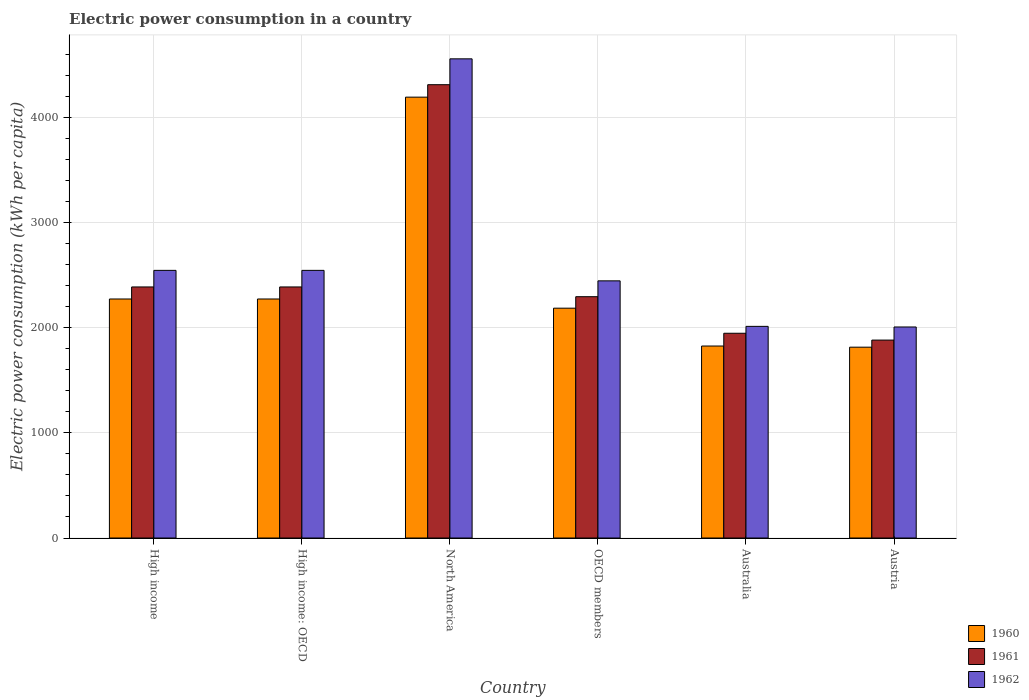What is the electric power consumption in in 1961 in High income?
Offer a terse response. 2387.51. Across all countries, what is the maximum electric power consumption in in 1962?
Provide a succinct answer. 4556.78. Across all countries, what is the minimum electric power consumption in in 1961?
Offer a very short reply. 1882.22. In which country was the electric power consumption in in 1961 minimum?
Give a very brief answer. Austria. What is the total electric power consumption in in 1961 in the graph?
Your answer should be very brief. 1.52e+04. What is the difference between the electric power consumption in in 1962 in Australia and that in North America?
Keep it short and to the point. -2544.12. What is the difference between the electric power consumption in in 1962 in High income and the electric power consumption in in 1960 in Australia?
Make the answer very short. 719.61. What is the average electric power consumption in in 1960 per country?
Your answer should be compact. 2427.36. What is the difference between the electric power consumption in of/in 1960 and electric power consumption in of/in 1962 in Australia?
Your response must be concise. -187.03. In how many countries, is the electric power consumption in in 1961 greater than 3000 kWh per capita?
Your response must be concise. 1. What is the ratio of the electric power consumption in in 1960 in Austria to that in OECD members?
Provide a short and direct response. 0.83. Is the electric power consumption in in 1962 in Australia less than that in Austria?
Keep it short and to the point. No. What is the difference between the highest and the second highest electric power consumption in in 1960?
Ensure brevity in your answer.  1919.38. What is the difference between the highest and the lowest electric power consumption in in 1960?
Ensure brevity in your answer.  2377.68. What does the 2nd bar from the left in Austria represents?
Offer a terse response. 1961. What does the 1st bar from the right in High income: OECD represents?
Give a very brief answer. 1962. How many legend labels are there?
Give a very brief answer. 3. What is the title of the graph?
Keep it short and to the point. Electric power consumption in a country. What is the label or title of the X-axis?
Provide a succinct answer. Country. What is the label or title of the Y-axis?
Offer a very short reply. Electric power consumption (kWh per capita). What is the Electric power consumption (kWh per capita) of 1960 in High income?
Provide a succinct answer. 2272.98. What is the Electric power consumption (kWh per capita) of 1961 in High income?
Ensure brevity in your answer.  2387.51. What is the Electric power consumption (kWh per capita) in 1962 in High income?
Your response must be concise. 2545.23. What is the Electric power consumption (kWh per capita) of 1960 in High income: OECD?
Ensure brevity in your answer.  2272.98. What is the Electric power consumption (kWh per capita) in 1961 in High income: OECD?
Offer a very short reply. 2387.51. What is the Electric power consumption (kWh per capita) in 1962 in High income: OECD?
Offer a very short reply. 2545.23. What is the Electric power consumption (kWh per capita) in 1960 in North America?
Offer a terse response. 4192.36. What is the Electric power consumption (kWh per capita) in 1961 in North America?
Ensure brevity in your answer.  4310.91. What is the Electric power consumption (kWh per capita) in 1962 in North America?
Provide a short and direct response. 4556.78. What is the Electric power consumption (kWh per capita) in 1960 in OECD members?
Ensure brevity in your answer.  2185.53. What is the Electric power consumption (kWh per capita) in 1961 in OECD members?
Provide a short and direct response. 2294.73. What is the Electric power consumption (kWh per capita) in 1962 in OECD members?
Offer a very short reply. 2445.52. What is the Electric power consumption (kWh per capita) of 1960 in Australia?
Your response must be concise. 1825.63. What is the Electric power consumption (kWh per capita) of 1961 in Australia?
Your answer should be very brief. 1947.15. What is the Electric power consumption (kWh per capita) in 1962 in Australia?
Provide a succinct answer. 2012.66. What is the Electric power consumption (kWh per capita) in 1960 in Austria?
Offer a terse response. 1814.68. What is the Electric power consumption (kWh per capita) of 1961 in Austria?
Your answer should be compact. 1882.22. What is the Electric power consumption (kWh per capita) of 1962 in Austria?
Offer a terse response. 2006.77. Across all countries, what is the maximum Electric power consumption (kWh per capita) of 1960?
Provide a short and direct response. 4192.36. Across all countries, what is the maximum Electric power consumption (kWh per capita) of 1961?
Offer a terse response. 4310.91. Across all countries, what is the maximum Electric power consumption (kWh per capita) of 1962?
Make the answer very short. 4556.78. Across all countries, what is the minimum Electric power consumption (kWh per capita) in 1960?
Your answer should be very brief. 1814.68. Across all countries, what is the minimum Electric power consumption (kWh per capita) in 1961?
Offer a terse response. 1882.22. Across all countries, what is the minimum Electric power consumption (kWh per capita) of 1962?
Ensure brevity in your answer.  2006.77. What is the total Electric power consumption (kWh per capita) of 1960 in the graph?
Offer a very short reply. 1.46e+04. What is the total Electric power consumption (kWh per capita) in 1961 in the graph?
Provide a short and direct response. 1.52e+04. What is the total Electric power consumption (kWh per capita) in 1962 in the graph?
Your answer should be very brief. 1.61e+04. What is the difference between the Electric power consumption (kWh per capita) of 1960 in High income and that in High income: OECD?
Provide a short and direct response. 0. What is the difference between the Electric power consumption (kWh per capita) of 1961 in High income and that in High income: OECD?
Give a very brief answer. 0. What is the difference between the Electric power consumption (kWh per capita) in 1960 in High income and that in North America?
Offer a terse response. -1919.38. What is the difference between the Electric power consumption (kWh per capita) of 1961 in High income and that in North America?
Give a very brief answer. -1923.4. What is the difference between the Electric power consumption (kWh per capita) in 1962 in High income and that in North America?
Your answer should be compact. -2011.55. What is the difference between the Electric power consumption (kWh per capita) of 1960 in High income and that in OECD members?
Keep it short and to the point. 87.44. What is the difference between the Electric power consumption (kWh per capita) in 1961 in High income and that in OECD members?
Make the answer very short. 92.77. What is the difference between the Electric power consumption (kWh per capita) in 1962 in High income and that in OECD members?
Your answer should be compact. 99.71. What is the difference between the Electric power consumption (kWh per capita) in 1960 in High income and that in Australia?
Offer a terse response. 447.35. What is the difference between the Electric power consumption (kWh per capita) in 1961 in High income and that in Australia?
Offer a very short reply. 440.35. What is the difference between the Electric power consumption (kWh per capita) of 1962 in High income and that in Australia?
Offer a very short reply. 532.57. What is the difference between the Electric power consumption (kWh per capita) in 1960 in High income and that in Austria?
Make the answer very short. 458.3. What is the difference between the Electric power consumption (kWh per capita) of 1961 in High income and that in Austria?
Your answer should be very brief. 505.28. What is the difference between the Electric power consumption (kWh per capita) of 1962 in High income and that in Austria?
Provide a short and direct response. 538.46. What is the difference between the Electric power consumption (kWh per capita) in 1960 in High income: OECD and that in North America?
Offer a terse response. -1919.38. What is the difference between the Electric power consumption (kWh per capita) in 1961 in High income: OECD and that in North America?
Offer a terse response. -1923.4. What is the difference between the Electric power consumption (kWh per capita) of 1962 in High income: OECD and that in North America?
Keep it short and to the point. -2011.55. What is the difference between the Electric power consumption (kWh per capita) of 1960 in High income: OECD and that in OECD members?
Offer a very short reply. 87.44. What is the difference between the Electric power consumption (kWh per capita) of 1961 in High income: OECD and that in OECD members?
Offer a terse response. 92.77. What is the difference between the Electric power consumption (kWh per capita) in 1962 in High income: OECD and that in OECD members?
Provide a succinct answer. 99.71. What is the difference between the Electric power consumption (kWh per capita) in 1960 in High income: OECD and that in Australia?
Your answer should be compact. 447.35. What is the difference between the Electric power consumption (kWh per capita) of 1961 in High income: OECD and that in Australia?
Your answer should be compact. 440.35. What is the difference between the Electric power consumption (kWh per capita) of 1962 in High income: OECD and that in Australia?
Offer a terse response. 532.57. What is the difference between the Electric power consumption (kWh per capita) in 1960 in High income: OECD and that in Austria?
Provide a short and direct response. 458.3. What is the difference between the Electric power consumption (kWh per capita) in 1961 in High income: OECD and that in Austria?
Your response must be concise. 505.28. What is the difference between the Electric power consumption (kWh per capita) of 1962 in High income: OECD and that in Austria?
Give a very brief answer. 538.46. What is the difference between the Electric power consumption (kWh per capita) in 1960 in North America and that in OECD members?
Ensure brevity in your answer.  2006.82. What is the difference between the Electric power consumption (kWh per capita) of 1961 in North America and that in OECD members?
Your answer should be very brief. 2016.17. What is the difference between the Electric power consumption (kWh per capita) in 1962 in North America and that in OECD members?
Keep it short and to the point. 2111.25. What is the difference between the Electric power consumption (kWh per capita) of 1960 in North America and that in Australia?
Your response must be concise. 2366.73. What is the difference between the Electric power consumption (kWh per capita) of 1961 in North America and that in Australia?
Offer a very short reply. 2363.75. What is the difference between the Electric power consumption (kWh per capita) in 1962 in North America and that in Australia?
Provide a short and direct response. 2544.12. What is the difference between the Electric power consumption (kWh per capita) of 1960 in North America and that in Austria?
Give a very brief answer. 2377.68. What is the difference between the Electric power consumption (kWh per capita) of 1961 in North America and that in Austria?
Your answer should be very brief. 2428.68. What is the difference between the Electric power consumption (kWh per capita) in 1962 in North America and that in Austria?
Make the answer very short. 2550.01. What is the difference between the Electric power consumption (kWh per capita) in 1960 in OECD members and that in Australia?
Your answer should be compact. 359.91. What is the difference between the Electric power consumption (kWh per capita) in 1961 in OECD members and that in Australia?
Offer a very short reply. 347.58. What is the difference between the Electric power consumption (kWh per capita) in 1962 in OECD members and that in Australia?
Make the answer very short. 432.86. What is the difference between the Electric power consumption (kWh per capita) in 1960 in OECD members and that in Austria?
Make the answer very short. 370.86. What is the difference between the Electric power consumption (kWh per capita) in 1961 in OECD members and that in Austria?
Provide a succinct answer. 412.51. What is the difference between the Electric power consumption (kWh per capita) in 1962 in OECD members and that in Austria?
Make the answer very short. 438.75. What is the difference between the Electric power consumption (kWh per capita) in 1960 in Australia and that in Austria?
Provide a short and direct response. 10.95. What is the difference between the Electric power consumption (kWh per capita) of 1961 in Australia and that in Austria?
Your response must be concise. 64.93. What is the difference between the Electric power consumption (kWh per capita) in 1962 in Australia and that in Austria?
Offer a terse response. 5.89. What is the difference between the Electric power consumption (kWh per capita) in 1960 in High income and the Electric power consumption (kWh per capita) in 1961 in High income: OECD?
Ensure brevity in your answer.  -114.53. What is the difference between the Electric power consumption (kWh per capita) of 1960 in High income and the Electric power consumption (kWh per capita) of 1962 in High income: OECD?
Make the answer very short. -272.26. What is the difference between the Electric power consumption (kWh per capita) of 1961 in High income and the Electric power consumption (kWh per capita) of 1962 in High income: OECD?
Provide a succinct answer. -157.73. What is the difference between the Electric power consumption (kWh per capita) in 1960 in High income and the Electric power consumption (kWh per capita) in 1961 in North America?
Offer a terse response. -2037.93. What is the difference between the Electric power consumption (kWh per capita) of 1960 in High income and the Electric power consumption (kWh per capita) of 1962 in North America?
Provide a short and direct response. -2283.8. What is the difference between the Electric power consumption (kWh per capita) in 1961 in High income and the Electric power consumption (kWh per capita) in 1962 in North America?
Offer a very short reply. -2169.27. What is the difference between the Electric power consumption (kWh per capita) of 1960 in High income and the Electric power consumption (kWh per capita) of 1961 in OECD members?
Provide a succinct answer. -21.76. What is the difference between the Electric power consumption (kWh per capita) of 1960 in High income and the Electric power consumption (kWh per capita) of 1962 in OECD members?
Offer a very short reply. -172.55. What is the difference between the Electric power consumption (kWh per capita) in 1961 in High income and the Electric power consumption (kWh per capita) in 1962 in OECD members?
Give a very brief answer. -58.02. What is the difference between the Electric power consumption (kWh per capita) of 1960 in High income and the Electric power consumption (kWh per capita) of 1961 in Australia?
Offer a very short reply. 325.82. What is the difference between the Electric power consumption (kWh per capita) of 1960 in High income and the Electric power consumption (kWh per capita) of 1962 in Australia?
Keep it short and to the point. 260.32. What is the difference between the Electric power consumption (kWh per capita) of 1961 in High income and the Electric power consumption (kWh per capita) of 1962 in Australia?
Make the answer very short. 374.84. What is the difference between the Electric power consumption (kWh per capita) of 1960 in High income and the Electric power consumption (kWh per capita) of 1961 in Austria?
Make the answer very short. 390.75. What is the difference between the Electric power consumption (kWh per capita) of 1960 in High income and the Electric power consumption (kWh per capita) of 1962 in Austria?
Your answer should be very brief. 266.21. What is the difference between the Electric power consumption (kWh per capita) in 1961 in High income and the Electric power consumption (kWh per capita) in 1962 in Austria?
Give a very brief answer. 380.73. What is the difference between the Electric power consumption (kWh per capita) in 1960 in High income: OECD and the Electric power consumption (kWh per capita) in 1961 in North America?
Your answer should be compact. -2037.93. What is the difference between the Electric power consumption (kWh per capita) in 1960 in High income: OECD and the Electric power consumption (kWh per capita) in 1962 in North America?
Give a very brief answer. -2283.8. What is the difference between the Electric power consumption (kWh per capita) in 1961 in High income: OECD and the Electric power consumption (kWh per capita) in 1962 in North America?
Make the answer very short. -2169.27. What is the difference between the Electric power consumption (kWh per capita) in 1960 in High income: OECD and the Electric power consumption (kWh per capita) in 1961 in OECD members?
Make the answer very short. -21.76. What is the difference between the Electric power consumption (kWh per capita) of 1960 in High income: OECD and the Electric power consumption (kWh per capita) of 1962 in OECD members?
Offer a very short reply. -172.55. What is the difference between the Electric power consumption (kWh per capita) in 1961 in High income: OECD and the Electric power consumption (kWh per capita) in 1962 in OECD members?
Your answer should be very brief. -58.02. What is the difference between the Electric power consumption (kWh per capita) in 1960 in High income: OECD and the Electric power consumption (kWh per capita) in 1961 in Australia?
Give a very brief answer. 325.82. What is the difference between the Electric power consumption (kWh per capita) in 1960 in High income: OECD and the Electric power consumption (kWh per capita) in 1962 in Australia?
Your answer should be compact. 260.32. What is the difference between the Electric power consumption (kWh per capita) in 1961 in High income: OECD and the Electric power consumption (kWh per capita) in 1962 in Australia?
Provide a short and direct response. 374.84. What is the difference between the Electric power consumption (kWh per capita) in 1960 in High income: OECD and the Electric power consumption (kWh per capita) in 1961 in Austria?
Give a very brief answer. 390.75. What is the difference between the Electric power consumption (kWh per capita) in 1960 in High income: OECD and the Electric power consumption (kWh per capita) in 1962 in Austria?
Your answer should be very brief. 266.21. What is the difference between the Electric power consumption (kWh per capita) in 1961 in High income: OECD and the Electric power consumption (kWh per capita) in 1962 in Austria?
Ensure brevity in your answer.  380.73. What is the difference between the Electric power consumption (kWh per capita) in 1960 in North America and the Electric power consumption (kWh per capita) in 1961 in OECD members?
Ensure brevity in your answer.  1897.62. What is the difference between the Electric power consumption (kWh per capita) of 1960 in North America and the Electric power consumption (kWh per capita) of 1962 in OECD members?
Give a very brief answer. 1746.83. What is the difference between the Electric power consumption (kWh per capita) in 1961 in North America and the Electric power consumption (kWh per capita) in 1962 in OECD members?
Ensure brevity in your answer.  1865.38. What is the difference between the Electric power consumption (kWh per capita) in 1960 in North America and the Electric power consumption (kWh per capita) in 1961 in Australia?
Give a very brief answer. 2245.2. What is the difference between the Electric power consumption (kWh per capita) in 1960 in North America and the Electric power consumption (kWh per capita) in 1962 in Australia?
Offer a terse response. 2179.7. What is the difference between the Electric power consumption (kWh per capita) of 1961 in North America and the Electric power consumption (kWh per capita) of 1962 in Australia?
Keep it short and to the point. 2298.24. What is the difference between the Electric power consumption (kWh per capita) of 1960 in North America and the Electric power consumption (kWh per capita) of 1961 in Austria?
Provide a succinct answer. 2310.13. What is the difference between the Electric power consumption (kWh per capita) in 1960 in North America and the Electric power consumption (kWh per capita) in 1962 in Austria?
Provide a short and direct response. 2185.59. What is the difference between the Electric power consumption (kWh per capita) of 1961 in North America and the Electric power consumption (kWh per capita) of 1962 in Austria?
Keep it short and to the point. 2304.13. What is the difference between the Electric power consumption (kWh per capita) in 1960 in OECD members and the Electric power consumption (kWh per capita) in 1961 in Australia?
Provide a short and direct response. 238.38. What is the difference between the Electric power consumption (kWh per capita) in 1960 in OECD members and the Electric power consumption (kWh per capita) in 1962 in Australia?
Provide a short and direct response. 172.87. What is the difference between the Electric power consumption (kWh per capita) of 1961 in OECD members and the Electric power consumption (kWh per capita) of 1962 in Australia?
Provide a short and direct response. 282.07. What is the difference between the Electric power consumption (kWh per capita) of 1960 in OECD members and the Electric power consumption (kWh per capita) of 1961 in Austria?
Offer a very short reply. 303.31. What is the difference between the Electric power consumption (kWh per capita) in 1960 in OECD members and the Electric power consumption (kWh per capita) in 1962 in Austria?
Offer a terse response. 178.76. What is the difference between the Electric power consumption (kWh per capita) of 1961 in OECD members and the Electric power consumption (kWh per capita) of 1962 in Austria?
Your answer should be very brief. 287.96. What is the difference between the Electric power consumption (kWh per capita) in 1960 in Australia and the Electric power consumption (kWh per capita) in 1961 in Austria?
Your answer should be very brief. -56.6. What is the difference between the Electric power consumption (kWh per capita) in 1960 in Australia and the Electric power consumption (kWh per capita) in 1962 in Austria?
Your answer should be compact. -181.14. What is the difference between the Electric power consumption (kWh per capita) of 1961 in Australia and the Electric power consumption (kWh per capita) of 1962 in Austria?
Your response must be concise. -59.62. What is the average Electric power consumption (kWh per capita) in 1960 per country?
Your answer should be compact. 2427.36. What is the average Electric power consumption (kWh per capita) in 1961 per country?
Your response must be concise. 2535. What is the average Electric power consumption (kWh per capita) of 1962 per country?
Your answer should be very brief. 2685.37. What is the difference between the Electric power consumption (kWh per capita) of 1960 and Electric power consumption (kWh per capita) of 1961 in High income?
Offer a terse response. -114.53. What is the difference between the Electric power consumption (kWh per capita) in 1960 and Electric power consumption (kWh per capita) in 1962 in High income?
Your answer should be very brief. -272.26. What is the difference between the Electric power consumption (kWh per capita) in 1961 and Electric power consumption (kWh per capita) in 1962 in High income?
Offer a very short reply. -157.73. What is the difference between the Electric power consumption (kWh per capita) of 1960 and Electric power consumption (kWh per capita) of 1961 in High income: OECD?
Give a very brief answer. -114.53. What is the difference between the Electric power consumption (kWh per capita) in 1960 and Electric power consumption (kWh per capita) in 1962 in High income: OECD?
Keep it short and to the point. -272.26. What is the difference between the Electric power consumption (kWh per capita) of 1961 and Electric power consumption (kWh per capita) of 1962 in High income: OECD?
Give a very brief answer. -157.73. What is the difference between the Electric power consumption (kWh per capita) of 1960 and Electric power consumption (kWh per capita) of 1961 in North America?
Offer a terse response. -118.55. What is the difference between the Electric power consumption (kWh per capita) in 1960 and Electric power consumption (kWh per capita) in 1962 in North America?
Your answer should be very brief. -364.42. What is the difference between the Electric power consumption (kWh per capita) of 1961 and Electric power consumption (kWh per capita) of 1962 in North America?
Ensure brevity in your answer.  -245.87. What is the difference between the Electric power consumption (kWh per capita) of 1960 and Electric power consumption (kWh per capita) of 1961 in OECD members?
Your answer should be very brief. -109.2. What is the difference between the Electric power consumption (kWh per capita) in 1960 and Electric power consumption (kWh per capita) in 1962 in OECD members?
Give a very brief answer. -259.99. What is the difference between the Electric power consumption (kWh per capita) in 1961 and Electric power consumption (kWh per capita) in 1962 in OECD members?
Your answer should be compact. -150.79. What is the difference between the Electric power consumption (kWh per capita) of 1960 and Electric power consumption (kWh per capita) of 1961 in Australia?
Provide a succinct answer. -121.53. What is the difference between the Electric power consumption (kWh per capita) in 1960 and Electric power consumption (kWh per capita) in 1962 in Australia?
Provide a succinct answer. -187.03. What is the difference between the Electric power consumption (kWh per capita) in 1961 and Electric power consumption (kWh per capita) in 1962 in Australia?
Your answer should be compact. -65.51. What is the difference between the Electric power consumption (kWh per capita) of 1960 and Electric power consumption (kWh per capita) of 1961 in Austria?
Provide a short and direct response. -67.55. What is the difference between the Electric power consumption (kWh per capita) of 1960 and Electric power consumption (kWh per capita) of 1962 in Austria?
Keep it short and to the point. -192.09. What is the difference between the Electric power consumption (kWh per capita) of 1961 and Electric power consumption (kWh per capita) of 1962 in Austria?
Provide a succinct answer. -124.55. What is the ratio of the Electric power consumption (kWh per capita) in 1962 in High income to that in High income: OECD?
Your answer should be compact. 1. What is the ratio of the Electric power consumption (kWh per capita) in 1960 in High income to that in North America?
Keep it short and to the point. 0.54. What is the ratio of the Electric power consumption (kWh per capita) in 1961 in High income to that in North America?
Offer a terse response. 0.55. What is the ratio of the Electric power consumption (kWh per capita) of 1962 in High income to that in North America?
Make the answer very short. 0.56. What is the ratio of the Electric power consumption (kWh per capita) in 1961 in High income to that in OECD members?
Keep it short and to the point. 1.04. What is the ratio of the Electric power consumption (kWh per capita) of 1962 in High income to that in OECD members?
Make the answer very short. 1.04. What is the ratio of the Electric power consumption (kWh per capita) in 1960 in High income to that in Australia?
Your response must be concise. 1.25. What is the ratio of the Electric power consumption (kWh per capita) in 1961 in High income to that in Australia?
Offer a terse response. 1.23. What is the ratio of the Electric power consumption (kWh per capita) of 1962 in High income to that in Australia?
Ensure brevity in your answer.  1.26. What is the ratio of the Electric power consumption (kWh per capita) in 1960 in High income to that in Austria?
Provide a short and direct response. 1.25. What is the ratio of the Electric power consumption (kWh per capita) in 1961 in High income to that in Austria?
Your answer should be very brief. 1.27. What is the ratio of the Electric power consumption (kWh per capita) of 1962 in High income to that in Austria?
Provide a short and direct response. 1.27. What is the ratio of the Electric power consumption (kWh per capita) of 1960 in High income: OECD to that in North America?
Offer a very short reply. 0.54. What is the ratio of the Electric power consumption (kWh per capita) of 1961 in High income: OECD to that in North America?
Your answer should be very brief. 0.55. What is the ratio of the Electric power consumption (kWh per capita) of 1962 in High income: OECD to that in North America?
Offer a very short reply. 0.56. What is the ratio of the Electric power consumption (kWh per capita) of 1960 in High income: OECD to that in OECD members?
Keep it short and to the point. 1.04. What is the ratio of the Electric power consumption (kWh per capita) of 1961 in High income: OECD to that in OECD members?
Your answer should be very brief. 1.04. What is the ratio of the Electric power consumption (kWh per capita) of 1962 in High income: OECD to that in OECD members?
Give a very brief answer. 1.04. What is the ratio of the Electric power consumption (kWh per capita) in 1960 in High income: OECD to that in Australia?
Offer a very short reply. 1.25. What is the ratio of the Electric power consumption (kWh per capita) in 1961 in High income: OECD to that in Australia?
Make the answer very short. 1.23. What is the ratio of the Electric power consumption (kWh per capita) in 1962 in High income: OECD to that in Australia?
Offer a very short reply. 1.26. What is the ratio of the Electric power consumption (kWh per capita) of 1960 in High income: OECD to that in Austria?
Provide a succinct answer. 1.25. What is the ratio of the Electric power consumption (kWh per capita) of 1961 in High income: OECD to that in Austria?
Provide a succinct answer. 1.27. What is the ratio of the Electric power consumption (kWh per capita) in 1962 in High income: OECD to that in Austria?
Make the answer very short. 1.27. What is the ratio of the Electric power consumption (kWh per capita) in 1960 in North America to that in OECD members?
Ensure brevity in your answer.  1.92. What is the ratio of the Electric power consumption (kWh per capita) of 1961 in North America to that in OECD members?
Offer a very short reply. 1.88. What is the ratio of the Electric power consumption (kWh per capita) in 1962 in North America to that in OECD members?
Provide a short and direct response. 1.86. What is the ratio of the Electric power consumption (kWh per capita) of 1960 in North America to that in Australia?
Make the answer very short. 2.3. What is the ratio of the Electric power consumption (kWh per capita) of 1961 in North America to that in Australia?
Ensure brevity in your answer.  2.21. What is the ratio of the Electric power consumption (kWh per capita) in 1962 in North America to that in Australia?
Give a very brief answer. 2.26. What is the ratio of the Electric power consumption (kWh per capita) of 1960 in North America to that in Austria?
Make the answer very short. 2.31. What is the ratio of the Electric power consumption (kWh per capita) of 1961 in North America to that in Austria?
Give a very brief answer. 2.29. What is the ratio of the Electric power consumption (kWh per capita) in 1962 in North America to that in Austria?
Your answer should be compact. 2.27. What is the ratio of the Electric power consumption (kWh per capita) of 1960 in OECD members to that in Australia?
Offer a very short reply. 1.2. What is the ratio of the Electric power consumption (kWh per capita) of 1961 in OECD members to that in Australia?
Your answer should be very brief. 1.18. What is the ratio of the Electric power consumption (kWh per capita) of 1962 in OECD members to that in Australia?
Give a very brief answer. 1.22. What is the ratio of the Electric power consumption (kWh per capita) in 1960 in OECD members to that in Austria?
Provide a succinct answer. 1.2. What is the ratio of the Electric power consumption (kWh per capita) of 1961 in OECD members to that in Austria?
Your answer should be compact. 1.22. What is the ratio of the Electric power consumption (kWh per capita) in 1962 in OECD members to that in Austria?
Your response must be concise. 1.22. What is the ratio of the Electric power consumption (kWh per capita) of 1960 in Australia to that in Austria?
Provide a succinct answer. 1.01. What is the ratio of the Electric power consumption (kWh per capita) of 1961 in Australia to that in Austria?
Offer a very short reply. 1.03. What is the difference between the highest and the second highest Electric power consumption (kWh per capita) in 1960?
Provide a short and direct response. 1919.38. What is the difference between the highest and the second highest Electric power consumption (kWh per capita) in 1961?
Keep it short and to the point. 1923.4. What is the difference between the highest and the second highest Electric power consumption (kWh per capita) of 1962?
Make the answer very short. 2011.55. What is the difference between the highest and the lowest Electric power consumption (kWh per capita) of 1960?
Keep it short and to the point. 2377.68. What is the difference between the highest and the lowest Electric power consumption (kWh per capita) of 1961?
Your response must be concise. 2428.68. What is the difference between the highest and the lowest Electric power consumption (kWh per capita) in 1962?
Your answer should be very brief. 2550.01. 